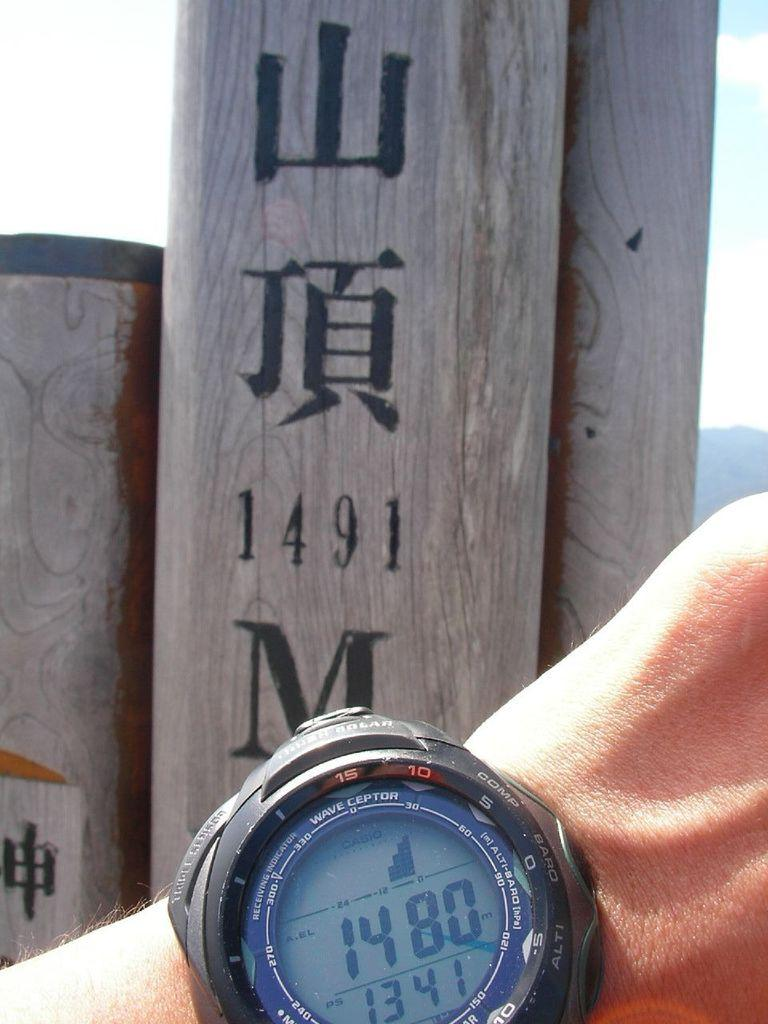Provide a one-sentence caption for the provided image. A wrist watch with the time 13 41 on the face. 